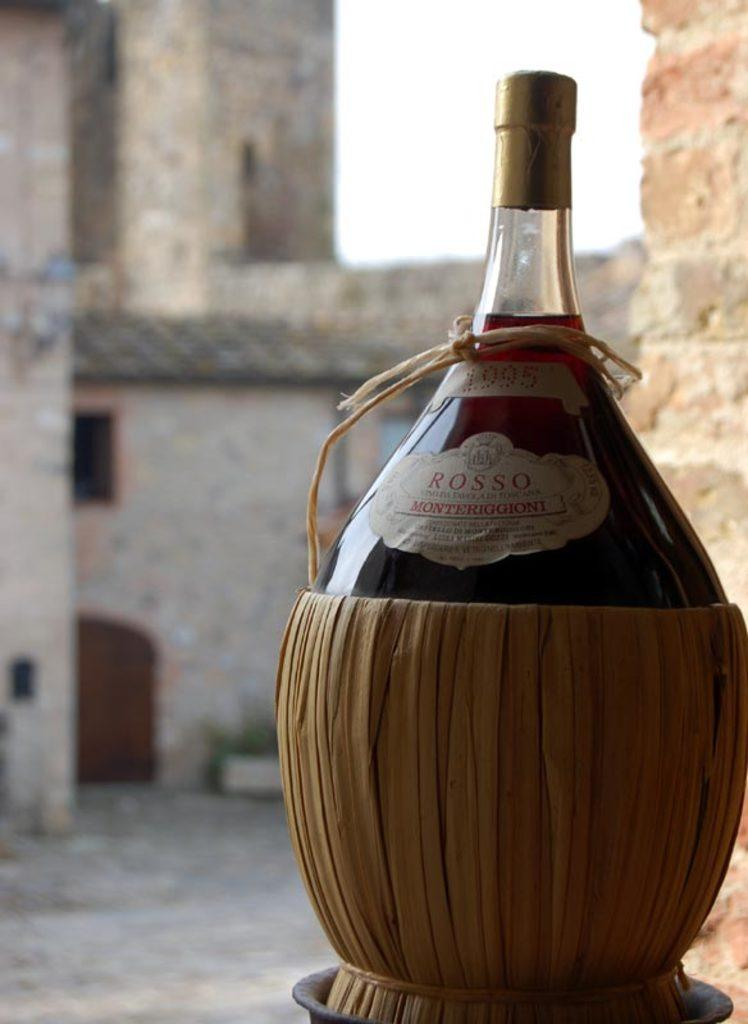What object is present in the image? There is a bottle in the image. How is the bottle being stored or carried? The bottle is packed in a basket. What can be seen in the background of the image? There is a wall and the sky visible in the background of the image. What force is being applied to the bottle in the image? There is no force being applied to the bottle in the image; it is simply packed in a basket. 